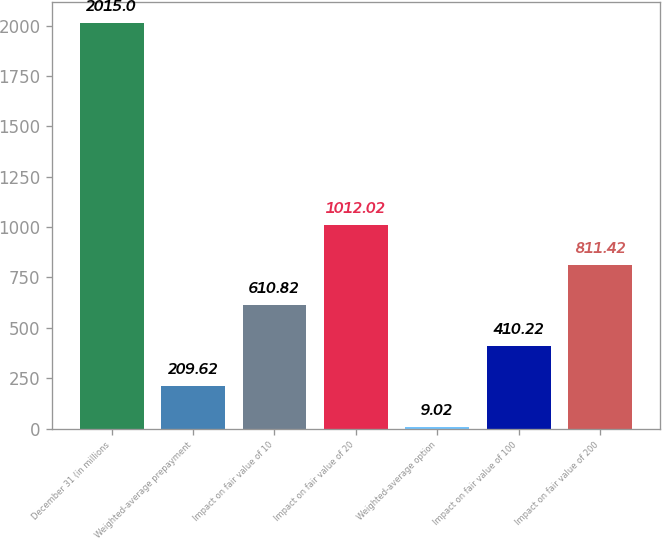<chart> <loc_0><loc_0><loc_500><loc_500><bar_chart><fcel>December 31 (in millions<fcel>Weighted-average prepayment<fcel>Impact on fair value of 10<fcel>Impact on fair value of 20<fcel>Weighted-average option<fcel>Impact on fair value of 100<fcel>Impact on fair value of 200<nl><fcel>2015<fcel>209.62<fcel>610.82<fcel>1012.02<fcel>9.02<fcel>410.22<fcel>811.42<nl></chart> 